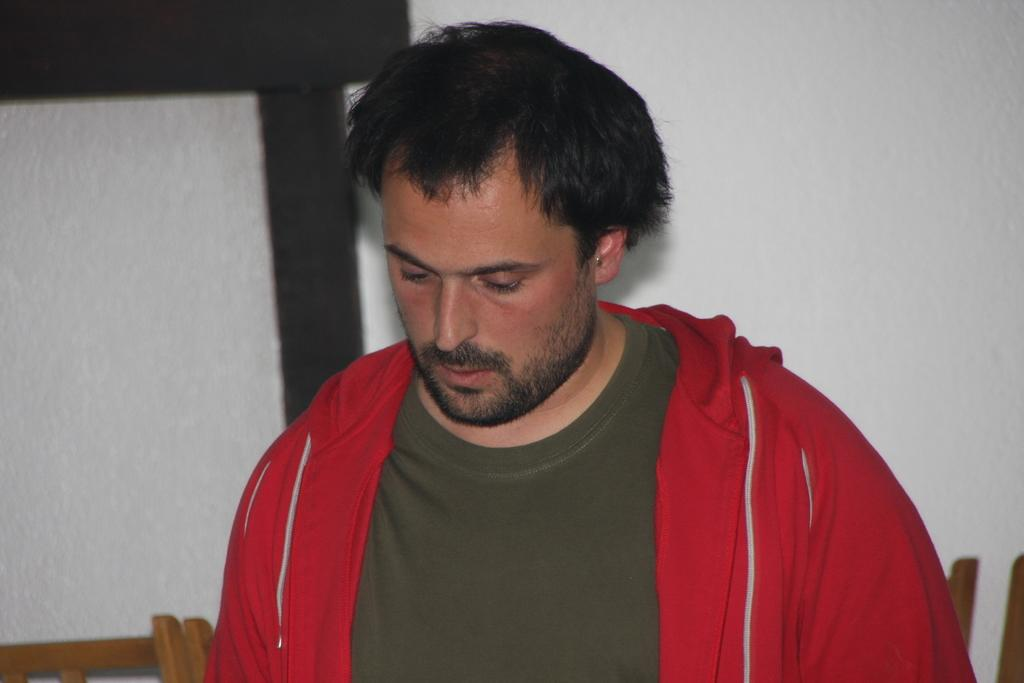Who or what is present in the image? There is a person in the image. What is the person wearing? The person is wearing a brown and red color dress. What can be seen in the background of the image? There are wooden objects in the background of the image. What color is the wall in the background? The wall in the background is white. Can you see any ink spilled on the person's dress in the image? No, there is no ink spilled on the person's dress in the image. Is there a giraffe visible in the image? No, there is no giraffe visible in the image. 